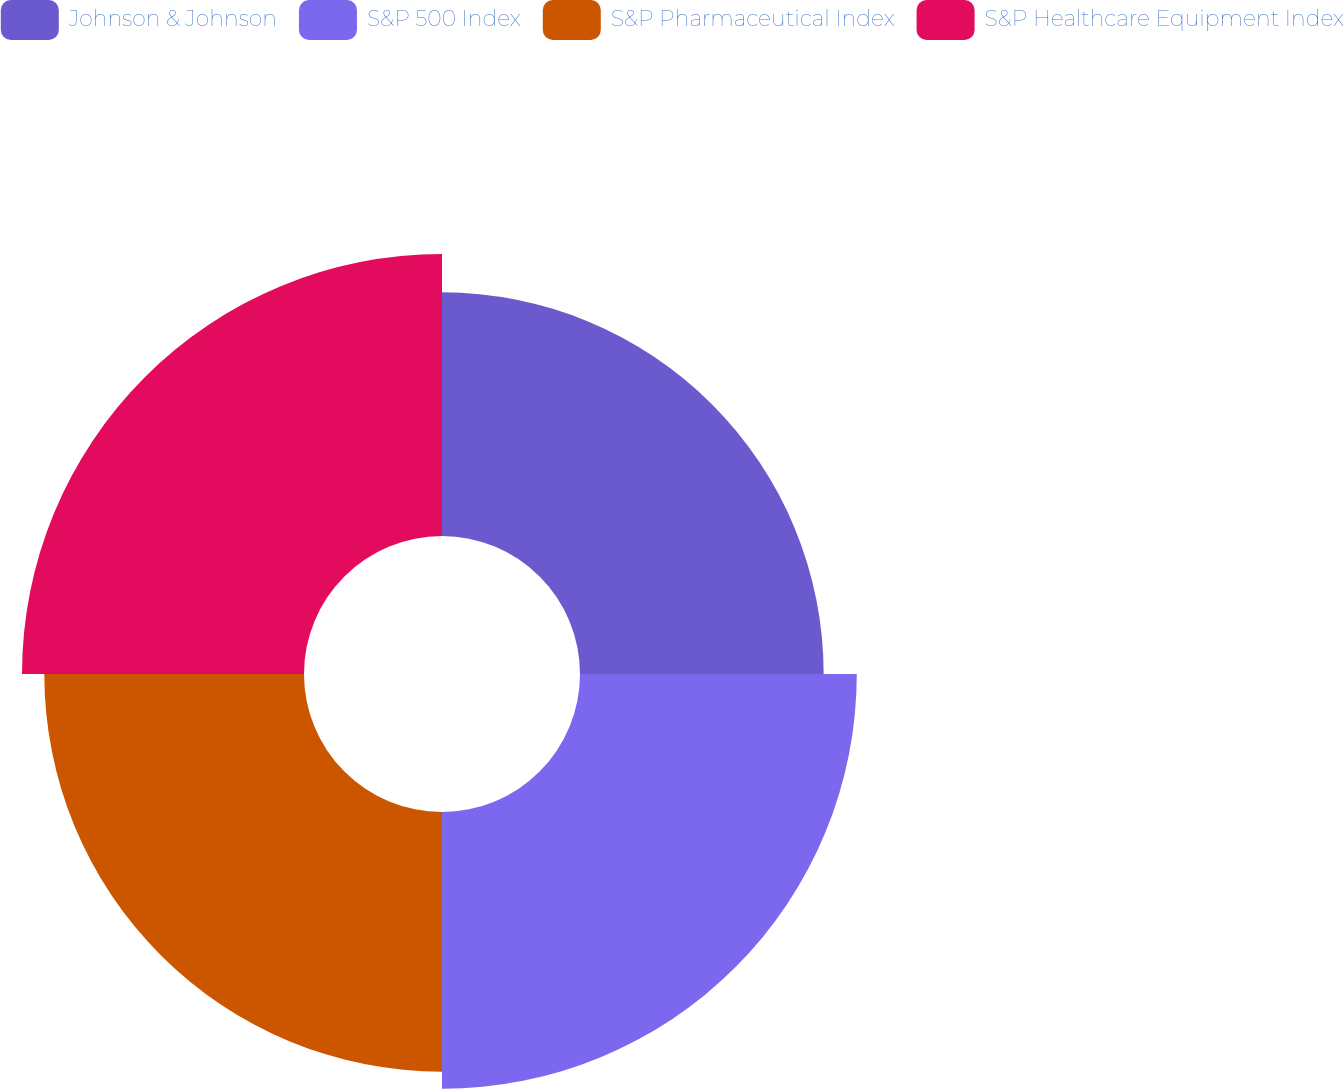Convert chart. <chart><loc_0><loc_0><loc_500><loc_500><pie_chart><fcel>Johnson & Johnson<fcel>S&P 500 Index<fcel>S&P Pharmaceutical Index<fcel>S&P Healthcare Equipment Index<nl><fcel>22.94%<fcel>26.06%<fcel>24.45%<fcel>26.55%<nl></chart> 